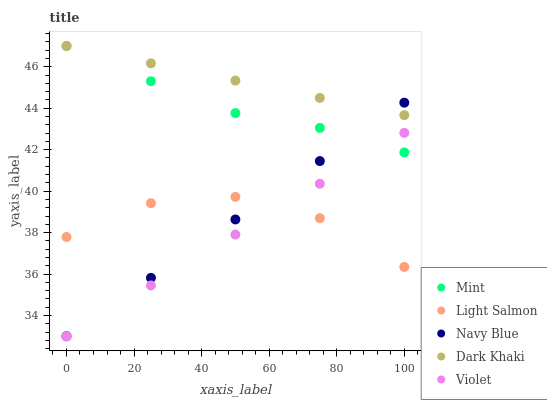Does Violet have the minimum area under the curve?
Answer yes or no. Yes. Does Dark Khaki have the maximum area under the curve?
Answer yes or no. Yes. Does Navy Blue have the minimum area under the curve?
Answer yes or no. No. Does Navy Blue have the maximum area under the curve?
Answer yes or no. No. Is Dark Khaki the smoothest?
Answer yes or no. Yes. Is Light Salmon the roughest?
Answer yes or no. Yes. Is Navy Blue the smoothest?
Answer yes or no. No. Is Navy Blue the roughest?
Answer yes or no. No. Does Navy Blue have the lowest value?
Answer yes or no. Yes. Does Light Salmon have the lowest value?
Answer yes or no. No. Does Mint have the highest value?
Answer yes or no. Yes. Does Navy Blue have the highest value?
Answer yes or no. No. Is Violet less than Dark Khaki?
Answer yes or no. Yes. Is Dark Khaki greater than Light Salmon?
Answer yes or no. Yes. Does Mint intersect Violet?
Answer yes or no. Yes. Is Mint less than Violet?
Answer yes or no. No. Is Mint greater than Violet?
Answer yes or no. No. Does Violet intersect Dark Khaki?
Answer yes or no. No. 